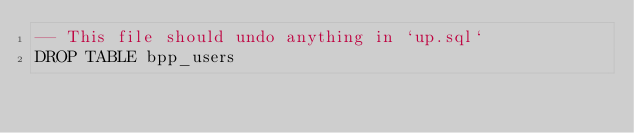<code> <loc_0><loc_0><loc_500><loc_500><_SQL_>-- This file should undo anything in `up.sql`
DROP TABLE bpp_users</code> 